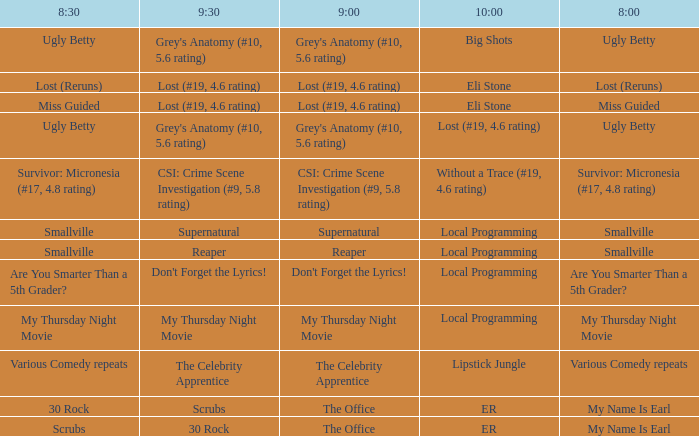What is at 8:00 when at 8:30 it is my thursday night movie? My Thursday Night Movie. 